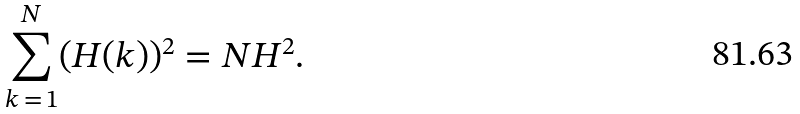Convert formula to latex. <formula><loc_0><loc_0><loc_500><loc_500>\sum _ { k \, = \, 1 } ^ { N } ( H ( k ) ) ^ { 2 } = N H ^ { 2 } .</formula> 